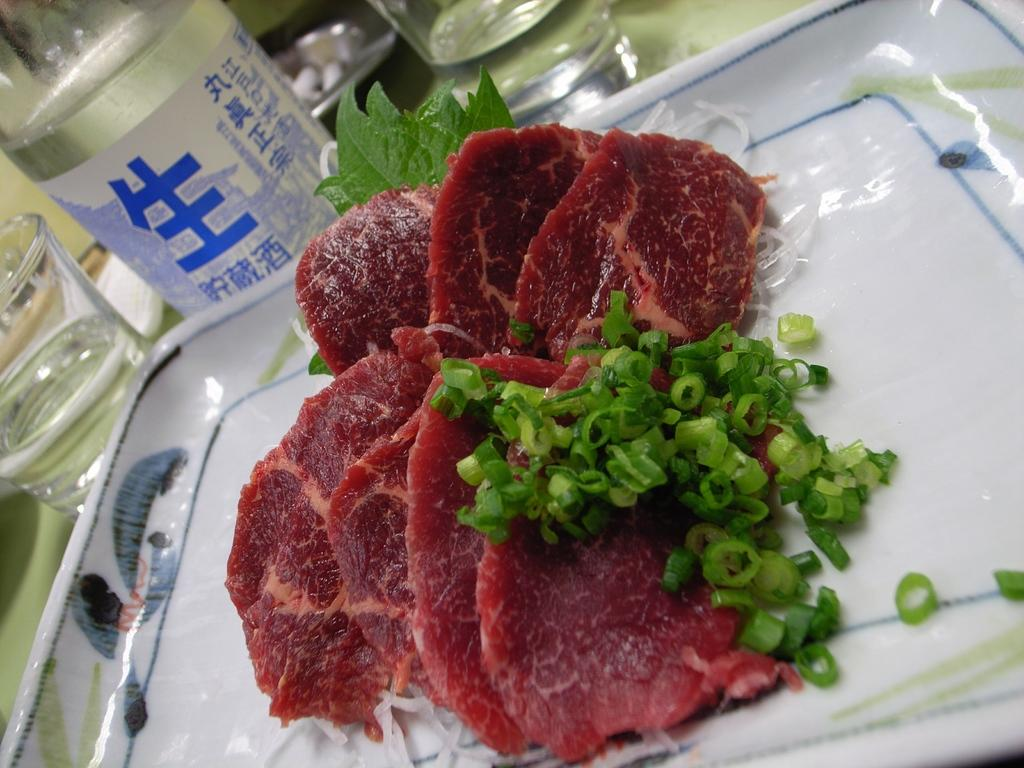What type of meat is in the image? There is red meat in the image. What other ingredients can be seen in the image? Chopped chilies, onions, and green leaves are visible in the image. What color is the tray in the image? The tray is white. What objects are in the background of the image? There are glasses and bottles on the table in the background. Can you see a group of snakes slithering around the red meat in the image? No, there are no snakes present in the image. What message of peace can be found in the image? There is no message of peace depicted in the image; it features red meat, chopped chilies, onions, green leaves, a white tray, glasses, and bottles. 